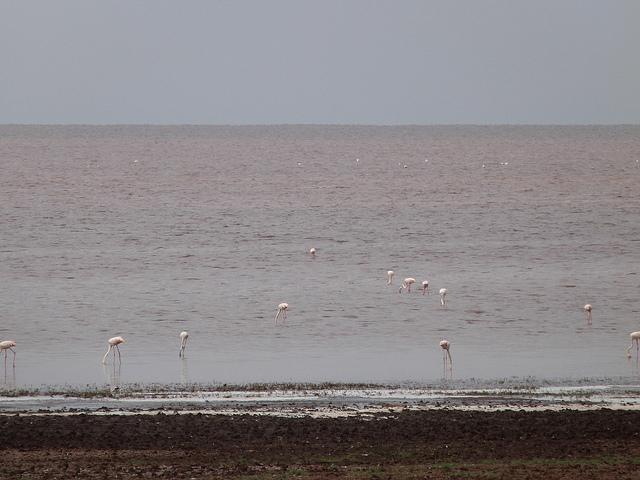What color will these birds become? pink 